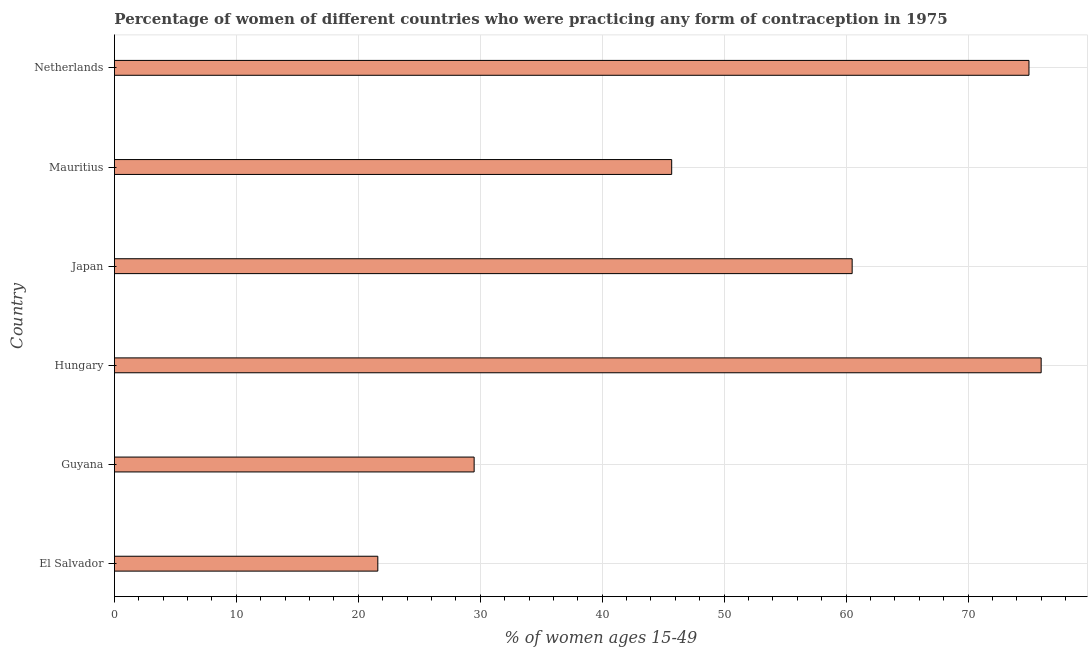Does the graph contain any zero values?
Give a very brief answer. No. What is the title of the graph?
Your response must be concise. Percentage of women of different countries who were practicing any form of contraception in 1975. What is the label or title of the X-axis?
Offer a terse response. % of women ages 15-49. What is the contraceptive prevalence in El Salvador?
Your answer should be very brief. 21.6. Across all countries, what is the maximum contraceptive prevalence?
Your response must be concise. 76. Across all countries, what is the minimum contraceptive prevalence?
Keep it short and to the point. 21.6. In which country was the contraceptive prevalence maximum?
Offer a terse response. Hungary. In which country was the contraceptive prevalence minimum?
Keep it short and to the point. El Salvador. What is the sum of the contraceptive prevalence?
Your answer should be very brief. 308.3. What is the difference between the contraceptive prevalence in Hungary and Netherlands?
Your response must be concise. 1. What is the average contraceptive prevalence per country?
Offer a very short reply. 51.38. What is the median contraceptive prevalence?
Ensure brevity in your answer.  53.1. What is the ratio of the contraceptive prevalence in El Salvador to that in Japan?
Your answer should be very brief. 0.36. What is the difference between the highest and the lowest contraceptive prevalence?
Offer a very short reply. 54.4. In how many countries, is the contraceptive prevalence greater than the average contraceptive prevalence taken over all countries?
Offer a very short reply. 3. How many countries are there in the graph?
Offer a terse response. 6. What is the difference between two consecutive major ticks on the X-axis?
Keep it short and to the point. 10. What is the % of women ages 15-49 in El Salvador?
Ensure brevity in your answer.  21.6. What is the % of women ages 15-49 of Guyana?
Ensure brevity in your answer.  29.5. What is the % of women ages 15-49 in Japan?
Offer a terse response. 60.5. What is the % of women ages 15-49 of Mauritius?
Make the answer very short. 45.7. What is the % of women ages 15-49 in Netherlands?
Give a very brief answer. 75. What is the difference between the % of women ages 15-49 in El Salvador and Hungary?
Provide a short and direct response. -54.4. What is the difference between the % of women ages 15-49 in El Salvador and Japan?
Keep it short and to the point. -38.9. What is the difference between the % of women ages 15-49 in El Salvador and Mauritius?
Provide a short and direct response. -24.1. What is the difference between the % of women ages 15-49 in El Salvador and Netherlands?
Your answer should be compact. -53.4. What is the difference between the % of women ages 15-49 in Guyana and Hungary?
Provide a short and direct response. -46.5. What is the difference between the % of women ages 15-49 in Guyana and Japan?
Your response must be concise. -31. What is the difference between the % of women ages 15-49 in Guyana and Mauritius?
Provide a short and direct response. -16.2. What is the difference between the % of women ages 15-49 in Guyana and Netherlands?
Keep it short and to the point. -45.5. What is the difference between the % of women ages 15-49 in Hungary and Japan?
Give a very brief answer. 15.5. What is the difference between the % of women ages 15-49 in Hungary and Mauritius?
Ensure brevity in your answer.  30.3. What is the difference between the % of women ages 15-49 in Hungary and Netherlands?
Your answer should be compact. 1. What is the difference between the % of women ages 15-49 in Japan and Mauritius?
Provide a succinct answer. 14.8. What is the difference between the % of women ages 15-49 in Mauritius and Netherlands?
Offer a very short reply. -29.3. What is the ratio of the % of women ages 15-49 in El Salvador to that in Guyana?
Provide a short and direct response. 0.73. What is the ratio of the % of women ages 15-49 in El Salvador to that in Hungary?
Your answer should be compact. 0.28. What is the ratio of the % of women ages 15-49 in El Salvador to that in Japan?
Your response must be concise. 0.36. What is the ratio of the % of women ages 15-49 in El Salvador to that in Mauritius?
Make the answer very short. 0.47. What is the ratio of the % of women ages 15-49 in El Salvador to that in Netherlands?
Your answer should be very brief. 0.29. What is the ratio of the % of women ages 15-49 in Guyana to that in Hungary?
Keep it short and to the point. 0.39. What is the ratio of the % of women ages 15-49 in Guyana to that in Japan?
Your answer should be very brief. 0.49. What is the ratio of the % of women ages 15-49 in Guyana to that in Mauritius?
Offer a very short reply. 0.65. What is the ratio of the % of women ages 15-49 in Guyana to that in Netherlands?
Your response must be concise. 0.39. What is the ratio of the % of women ages 15-49 in Hungary to that in Japan?
Make the answer very short. 1.26. What is the ratio of the % of women ages 15-49 in Hungary to that in Mauritius?
Your answer should be very brief. 1.66. What is the ratio of the % of women ages 15-49 in Hungary to that in Netherlands?
Your answer should be very brief. 1.01. What is the ratio of the % of women ages 15-49 in Japan to that in Mauritius?
Provide a succinct answer. 1.32. What is the ratio of the % of women ages 15-49 in Japan to that in Netherlands?
Offer a very short reply. 0.81. What is the ratio of the % of women ages 15-49 in Mauritius to that in Netherlands?
Your answer should be very brief. 0.61. 